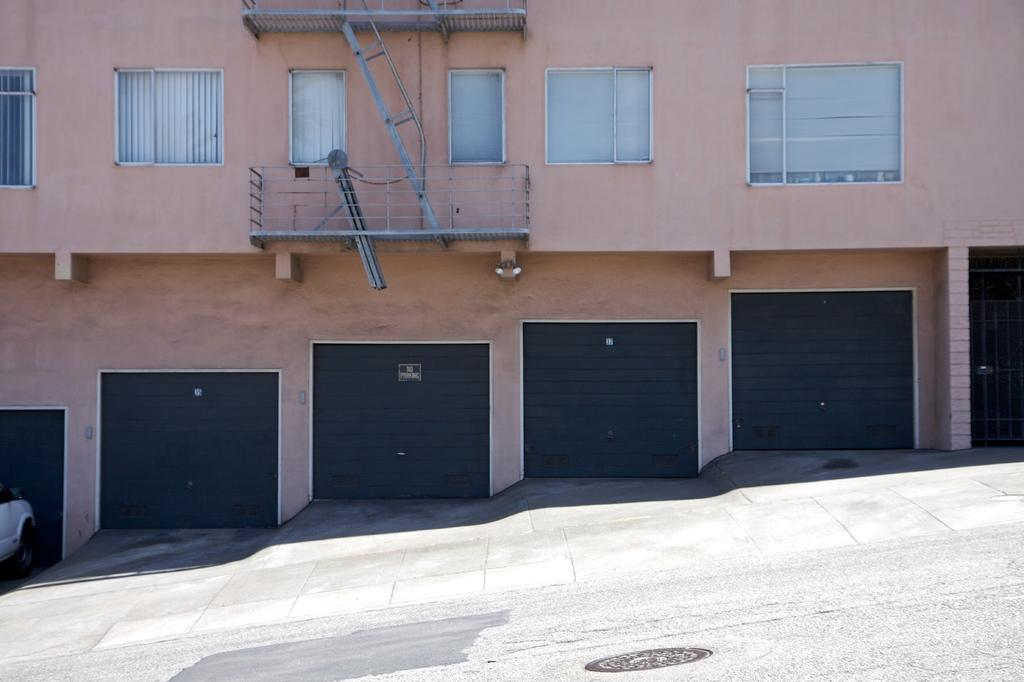What type of structure is visible in the image? There is a building in the image. What feature can be seen on the windows of the building? The building has glass windows. What additional feature can be seen on the building? The building has shutters. How can one enter the building? The building has a door. What security feature is present on the building? The building has a grille. What is at the bottom of the image? There is a road at the bottom of the image. What vehicle is visible in the image? There is a car on the left side of the image. What type of school is depicted in the image? There is no school depicted in the image; it features a building with various features and a car on the left side. What part of the building is made of underwear? There is no part of the building made of underwear; the building is constructed with more conventional materials. 